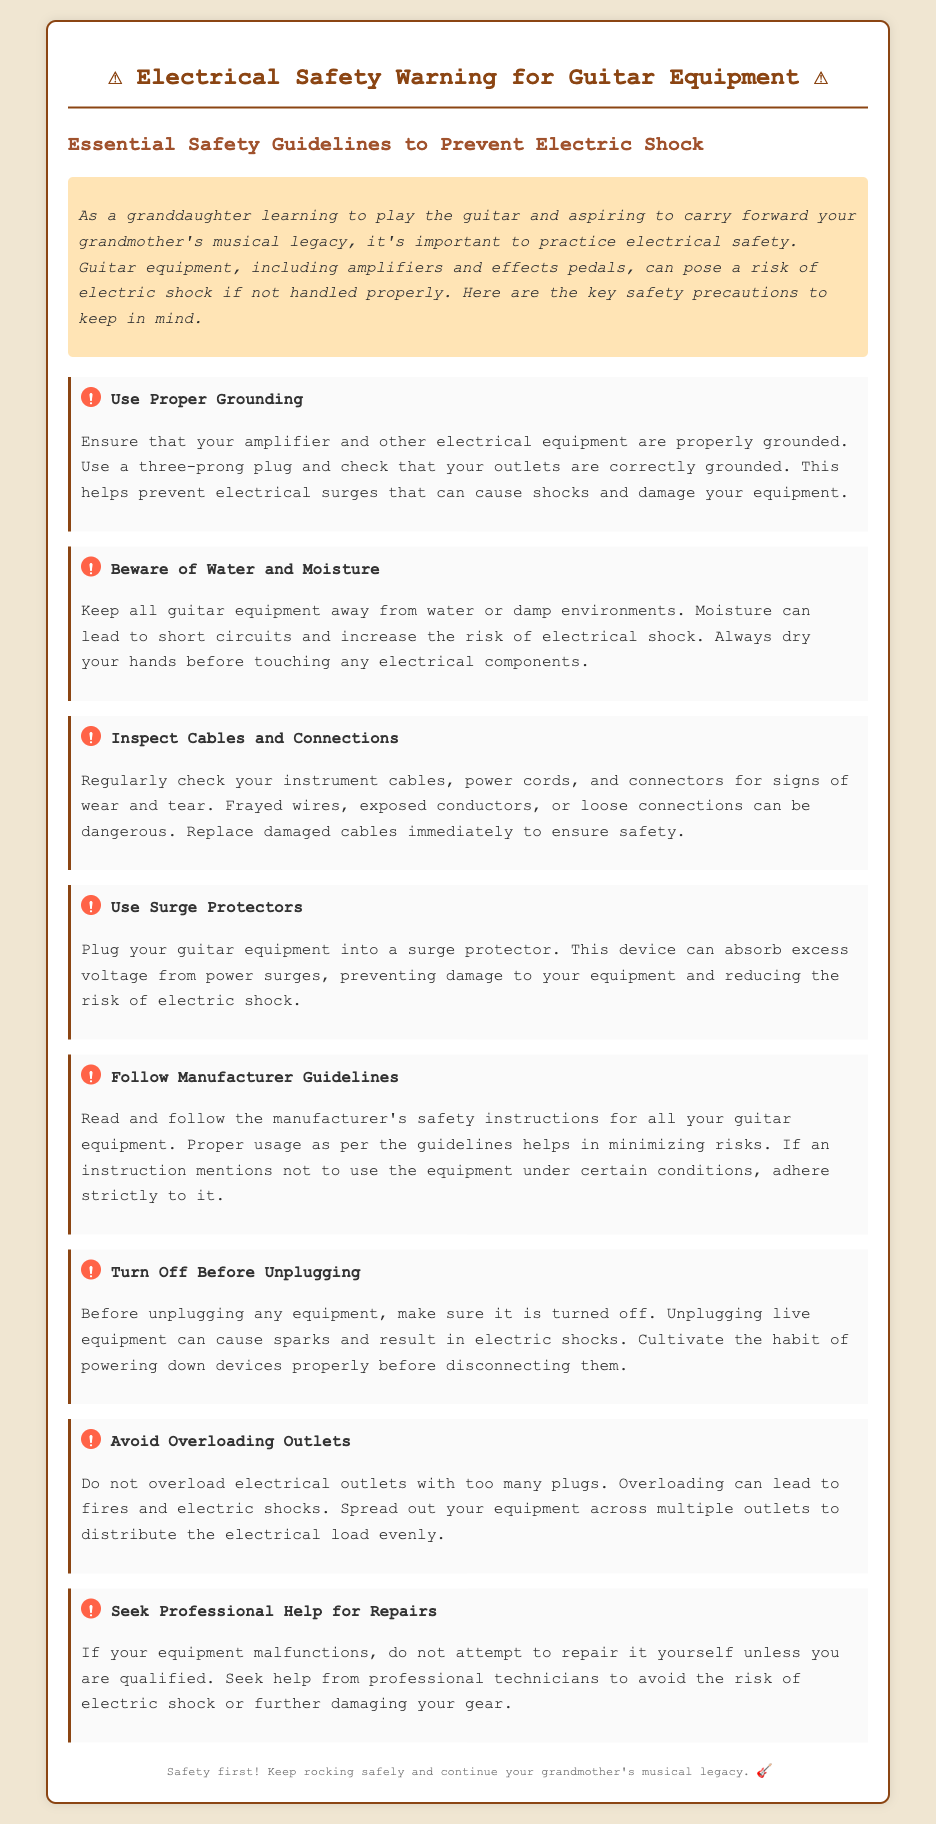What is the warning label about? The warning label addresses electrical safety precautions to prevent electric shock while using guitar equipment.
Answer: Electrical safety What should you use for grounding? The document specifies using a three-prong plug for proper grounding of electrical equipment.
Answer: Three-prong plug What must be done before unplugging equipment? It emphasizes that equipment should be turned off prior to unplugging it to avoid electric shock.
Answer: Turned off What should you regularly inspect for safety? The document advises checking instrument cables and power cords for signs of wear and tear.
Answer: Cables and connections What is recommended to avoid overloading outlets? The text suggests spreading out equipment across multiple outlets to prevent overload.
Answer: Multiple outlets What should be avoided to reduce electric shock risks? Keeping guitar equipment away from water or damp environments is advised to reduce shock risks.
Answer: Water and moisture What type of devices should guitar equipment be plugged into? Equipment should be plugged into surge protectors to handle excess voltage.
Answer: Surge protectors Who should repair malfunctioning equipment? It recommends seeking help from professional technicians rather than attempting to repair it oneself.
Answer: Professional technicians What is a critical precaution when handling electrical gear? Always dry your hands before touching any electrical components to prevent shock.
Answer: Dry hands 